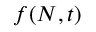Convert formula to latex. <formula><loc_0><loc_0><loc_500><loc_500>f ( N , t )</formula> 